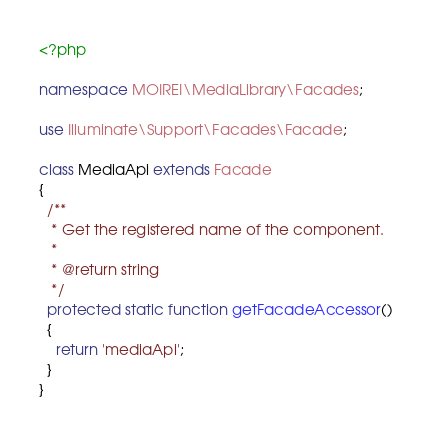Convert code to text. <code><loc_0><loc_0><loc_500><loc_500><_PHP_><?php

namespace MOIREI\MediaLibrary\Facades;

use Illuminate\Support\Facades\Facade;

class MediaApi extends Facade
{
  /**
   * Get the registered name of the component.
   *
   * @return string
   */
  protected static function getFacadeAccessor()
  {
    return 'mediaApi';
  }
}
</code> 